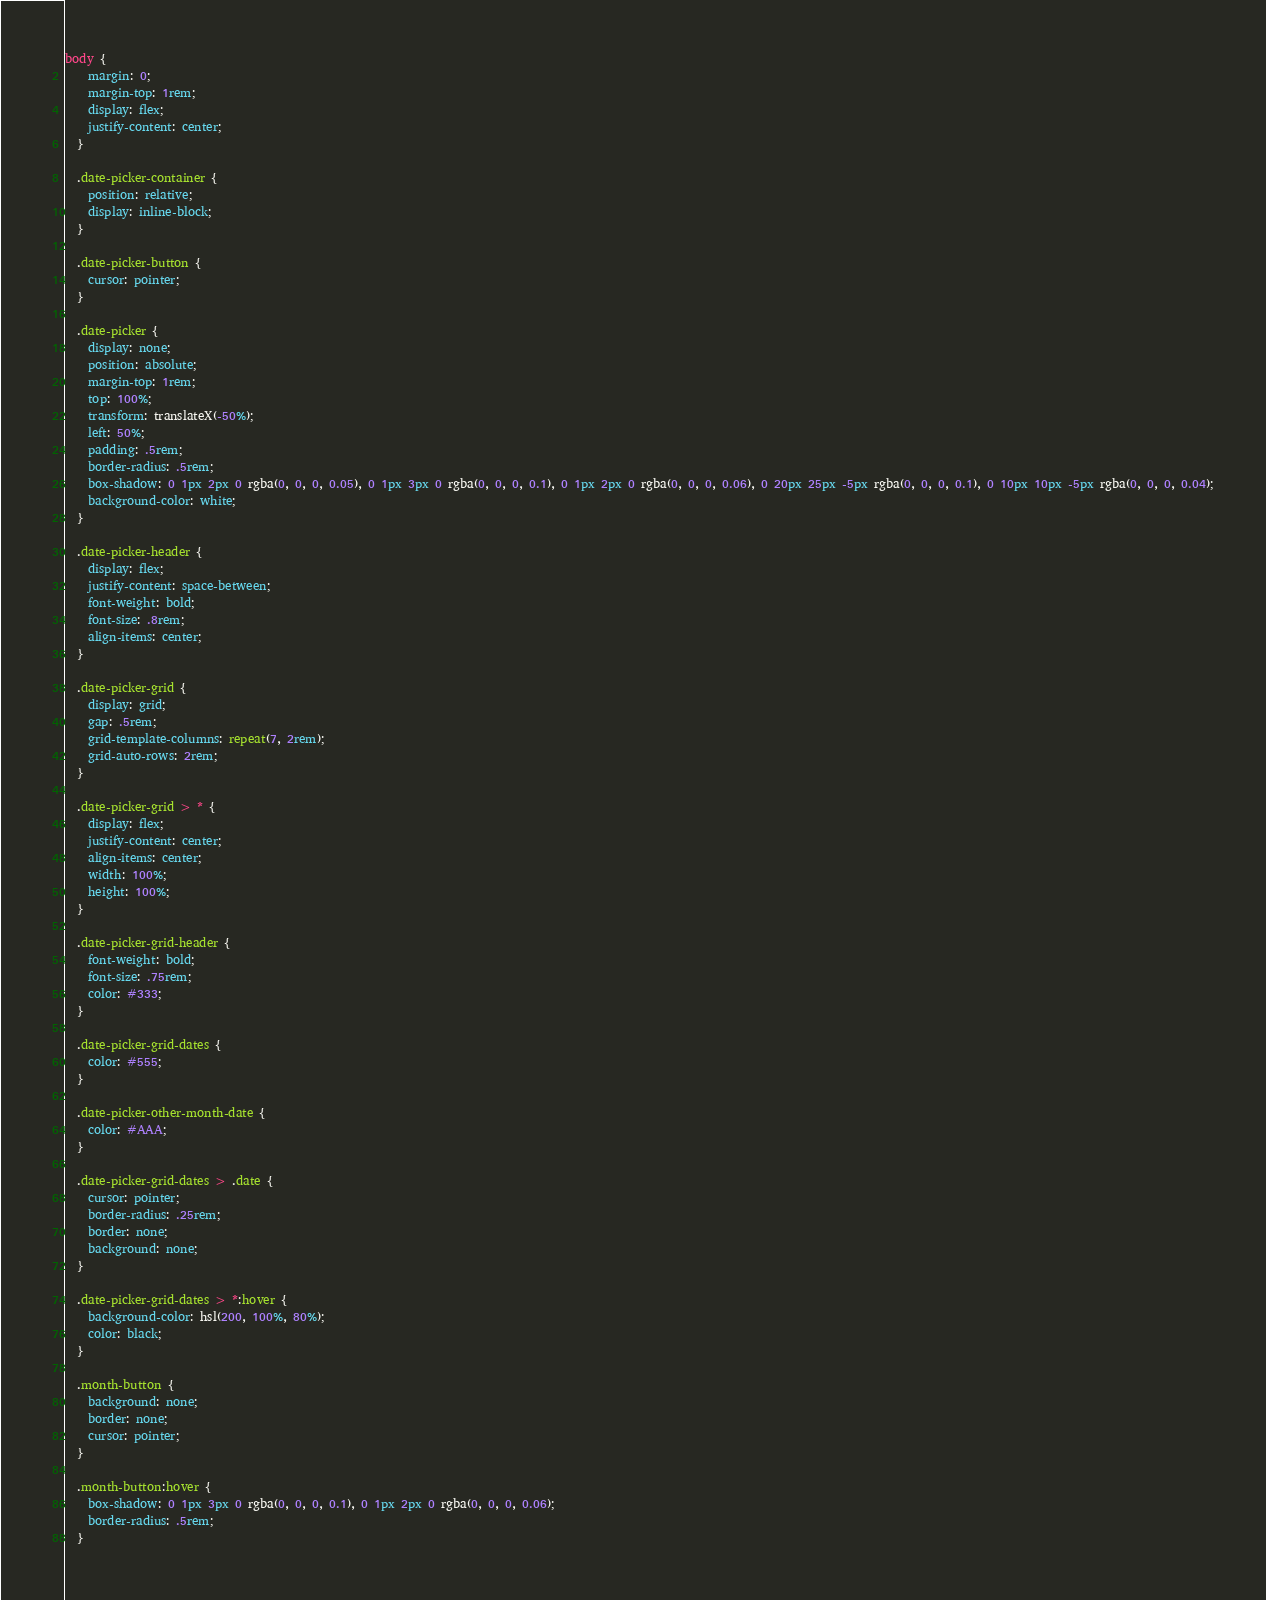<code> <loc_0><loc_0><loc_500><loc_500><_CSS_>body {
    margin: 0;
    margin-top: 1rem;
    display: flex;
    justify-content: center;
  }
  
  .date-picker-container {
    position: relative;
    display: inline-block;
  }
  
  .date-picker-button {
    cursor: pointer;
  }
  
  .date-picker {
    display: none;
    position: absolute;
    margin-top: 1rem;
    top: 100%;
    transform: translateX(-50%);
    left: 50%;
    padding: .5rem;
    border-radius: .5rem;
    box-shadow: 0 1px 2px 0 rgba(0, 0, 0, 0.05), 0 1px 3px 0 rgba(0, 0, 0, 0.1), 0 1px 2px 0 rgba(0, 0, 0, 0.06), 0 20px 25px -5px rgba(0, 0, 0, 0.1), 0 10px 10px -5px rgba(0, 0, 0, 0.04);
    background-color: white;
  }
  
  .date-picker-header {
    display: flex;
    justify-content: space-between;
    font-weight: bold;
    font-size: .8rem;
    align-items: center;
  }
  
  .date-picker-grid {
    display: grid;
    gap: .5rem;
    grid-template-columns: repeat(7, 2rem);
    grid-auto-rows: 2rem;
  }
  
  .date-picker-grid > * {
    display: flex;
    justify-content: center;
    align-items: center;
    width: 100%;
    height: 100%;
  }
  
  .date-picker-grid-header {
    font-weight: bold;
    font-size: .75rem;
    color: #333;
  }
  
  .date-picker-grid-dates {
    color: #555;
  }
  
  .date-picker-other-month-date {
    color: #AAA;
  }
  
  .date-picker-grid-dates > .date {
    cursor: pointer;
    border-radius: .25rem;
    border: none;
    background: none;
  }
  
  .date-picker-grid-dates > *:hover {
    background-color: hsl(200, 100%, 80%);
    color: black;
  }
  
  .month-button {
    background: none;
    border: none;
    cursor: pointer;
  }
  
  .month-button:hover {
    box-shadow: 0 1px 3px 0 rgba(0, 0, 0, 0.1), 0 1px 2px 0 rgba(0, 0, 0, 0.06);
    border-radius: .5rem;
  }</code> 